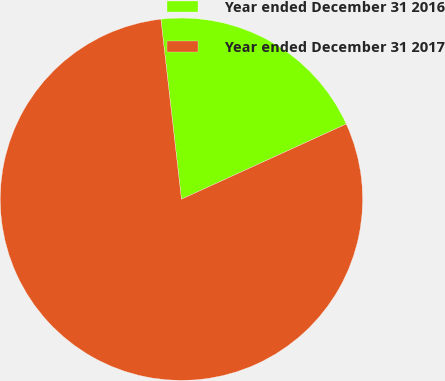Convert chart. <chart><loc_0><loc_0><loc_500><loc_500><pie_chart><fcel>Year ended December 31 2016<fcel>Year ended December 31 2017<nl><fcel>20.0%<fcel>80.0%<nl></chart> 